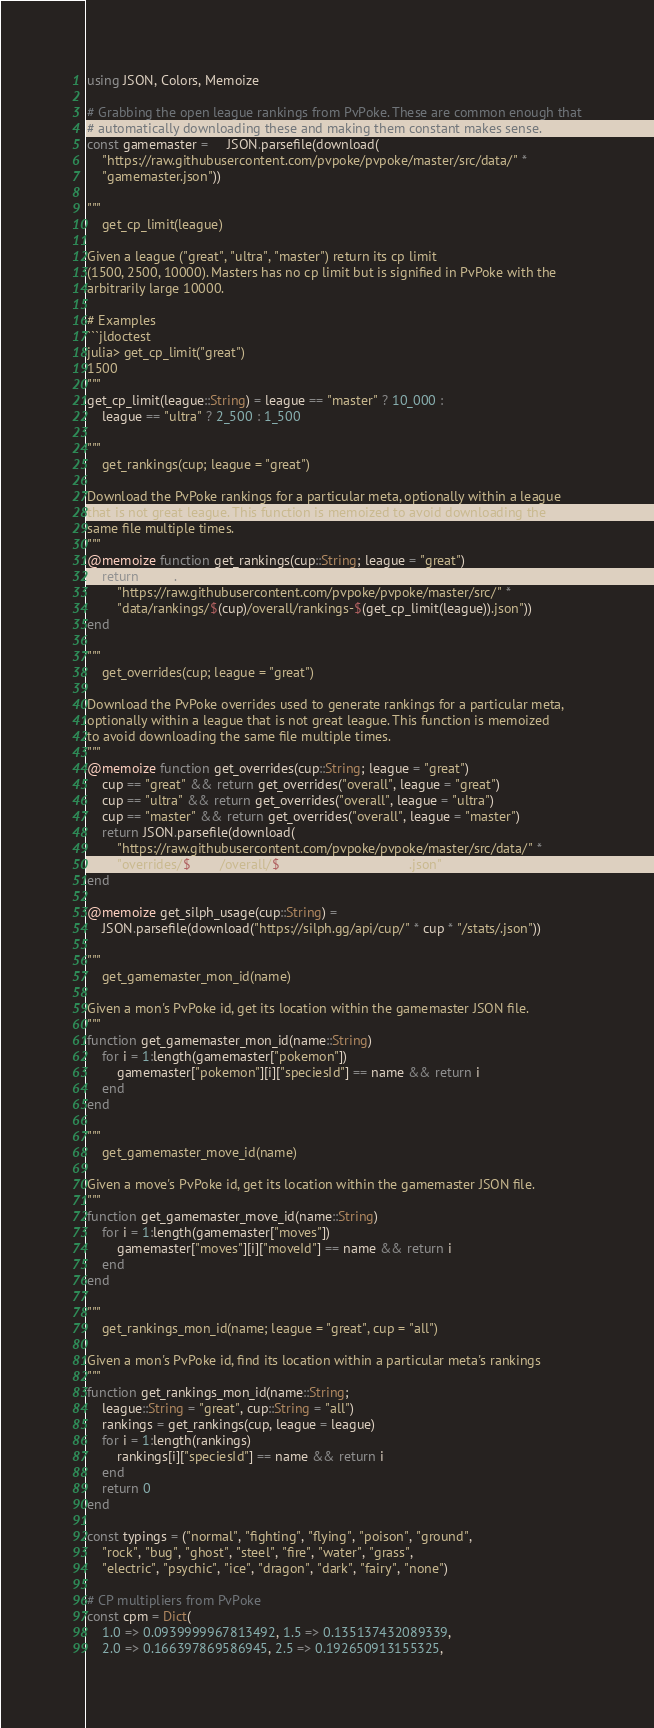Convert code to text. <code><loc_0><loc_0><loc_500><loc_500><_Julia_>using JSON, Colors, Memoize

# Grabbing the open league rankings from PvPoke. These are common enough that
# automatically downloading these and making them constant makes sense.
const gamemaster =     JSON.parsefile(download(
    "https://raw.githubusercontent.com/pvpoke/pvpoke/master/src/data/" *
    "gamemaster.json"))

"""
    get_cp_limit(league)

Given a league ("great", "ultra", "master") return its cp limit
(1500, 2500, 10000). Masters has no cp limit but is signified in PvPoke with the
arbitrarily large 10000.

# Examples
```jldoctest
julia> get_cp_limit("great")
1500
"""
get_cp_limit(league::String) = league == "master" ? 10_000 :
    league == "ultra" ? 2_500 : 1_500

"""
    get_rankings(cup; league = "great")

Download the PvPoke rankings for a particular meta, optionally within a league
that is not great league. This function is memoized to avoid downloading the
same file multiple times.
"""
@memoize function get_rankings(cup::String; league = "great")
    return JSON.parsefile(download(
        "https://raw.githubusercontent.com/pvpoke/pvpoke/master/src/" *
        "data/rankings/$(cup)/overall/rankings-$(get_cp_limit(league)).json"))
end

"""
    get_overrides(cup; league = "great")

Download the PvPoke overrides used to generate rankings for a particular meta,
optionally within a league that is not great league. This function is memoized
to avoid downloading the same file multiple times.
"""
@memoize function get_overrides(cup::String; league = "great")
    cup == "great" && return get_overrides("overall", league = "great")
    cup == "ultra" && return get_overrides("overall", league = "ultra")
    cup == "master" && return get_overrides("overall", league = "master")
    return JSON.parsefile(download(
        "https://raw.githubusercontent.com/pvpoke/pvpoke/master/src/data/" *
        "overrides/$(cup)/overall/$(get_cp_limit(league)).json"))
end

@memoize get_silph_usage(cup::String) =
    JSON.parsefile(download("https://silph.gg/api/cup/" * cup * "/stats/.json"))

"""
    get_gamemaster_mon_id(name)

Given a mon's PvPoke id, get its location within the gamemaster JSON file.
"""
function get_gamemaster_mon_id(name::String)
    for i = 1:length(gamemaster["pokemon"])
        gamemaster["pokemon"][i]["speciesId"] == name && return i
    end
end

"""
    get_gamemaster_move_id(name)

Given a move's PvPoke id, get its location within the gamemaster JSON file.
"""
function get_gamemaster_move_id(name::String)
    for i = 1:length(gamemaster["moves"])
        gamemaster["moves"][i]["moveId"] == name && return i
    end
end

"""
    get_rankings_mon_id(name; league = "great", cup = "all")

Given a mon's PvPoke id, find its location within a particular meta's rankings
"""
function get_rankings_mon_id(name::String;
    league::String = "great", cup::String = "all")
    rankings = get_rankings(cup, league = league)
    for i = 1:length(rankings)
        rankings[i]["speciesId"] == name && return i
    end
    return 0
end

const typings = ("normal", "fighting", "flying", "poison", "ground", 
    "rock", "bug", "ghost", "steel", "fire", "water", "grass", 
    "electric", "psychic", "ice", "dragon", "dark", "fairy", "none")

# CP multipliers from PvPoke
const cpm = Dict(
    1.0 => 0.0939999967813492, 1.5 => 0.135137432089339,
    2.0 => 0.166397869586945, 2.5 => 0.192650913155325,</code> 